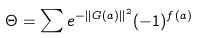<formula> <loc_0><loc_0><loc_500><loc_500>\Theta = \sum e ^ { - \| G ( a ) \| ^ { 2 } } ( - 1 ) ^ { f ( a ) }</formula> 